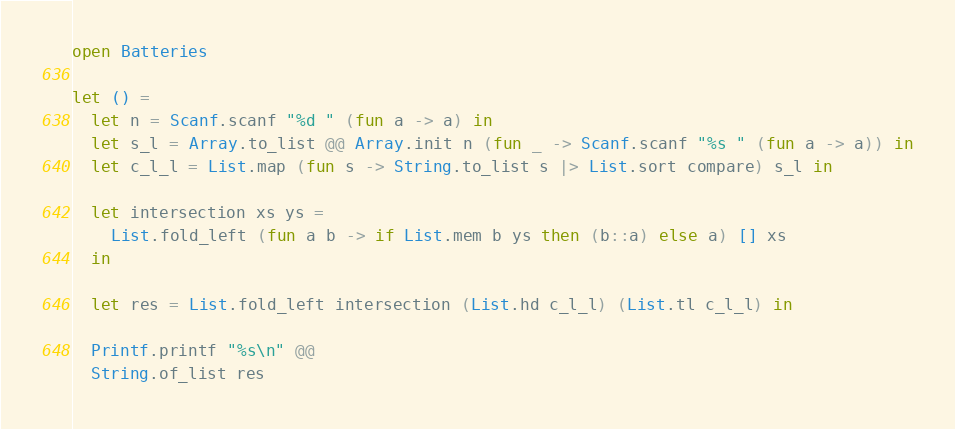Convert code to text. <code><loc_0><loc_0><loc_500><loc_500><_OCaml_>open Batteries

let () =
  let n = Scanf.scanf "%d " (fun a -> a) in
  let s_l = Array.to_list @@ Array.init n (fun _ -> Scanf.scanf "%s " (fun a -> a)) in
  let c_l_l = List.map (fun s -> String.to_list s |> List.sort compare) s_l in
  
  let intersection xs ys =
    List.fold_left (fun a b -> if List.mem b ys then (b::a) else a) [] xs
  in

  let res = List.fold_left intersection (List.hd c_l_l) (List.tl c_l_l) in

  Printf.printf "%s\n" @@
  String.of_list res

</code> 